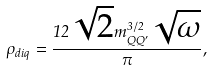<formula> <loc_0><loc_0><loc_500><loc_500>\rho _ { d i q } = \frac { 1 2 \sqrt { 2 } m _ { Q Q ^ { \prime } } ^ { 3 / 2 } \sqrt { \omega } } { \pi } ,</formula> 